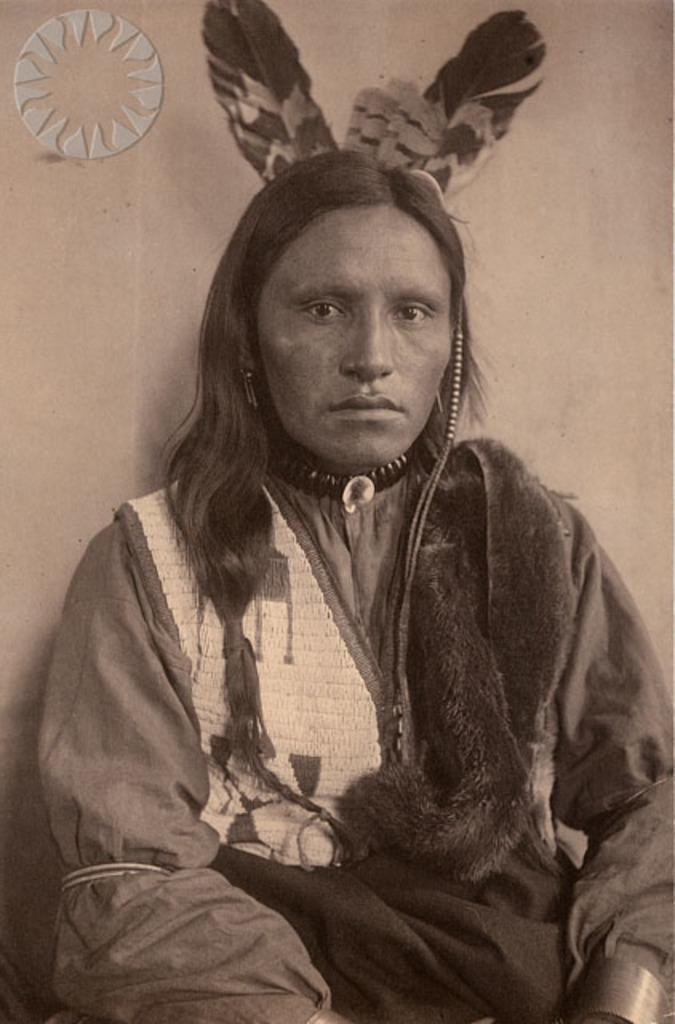Who is present in the image? There is a person in the image. What is the person wearing? The person is wearing a fancy dress. What is the person doing in the image? The person is sitting. What can be seen in the image besides the person? There are feathers and a wall in the image. Is there any indication of the image's origin or ownership? Yes, there is a watermark on the image. What type of volleyball game is being played in the image? There is no volleyball game present in the image. What trick does the person perform with the feathers in the image? There is no trick performed with the feathers in the image; they are simply present. 